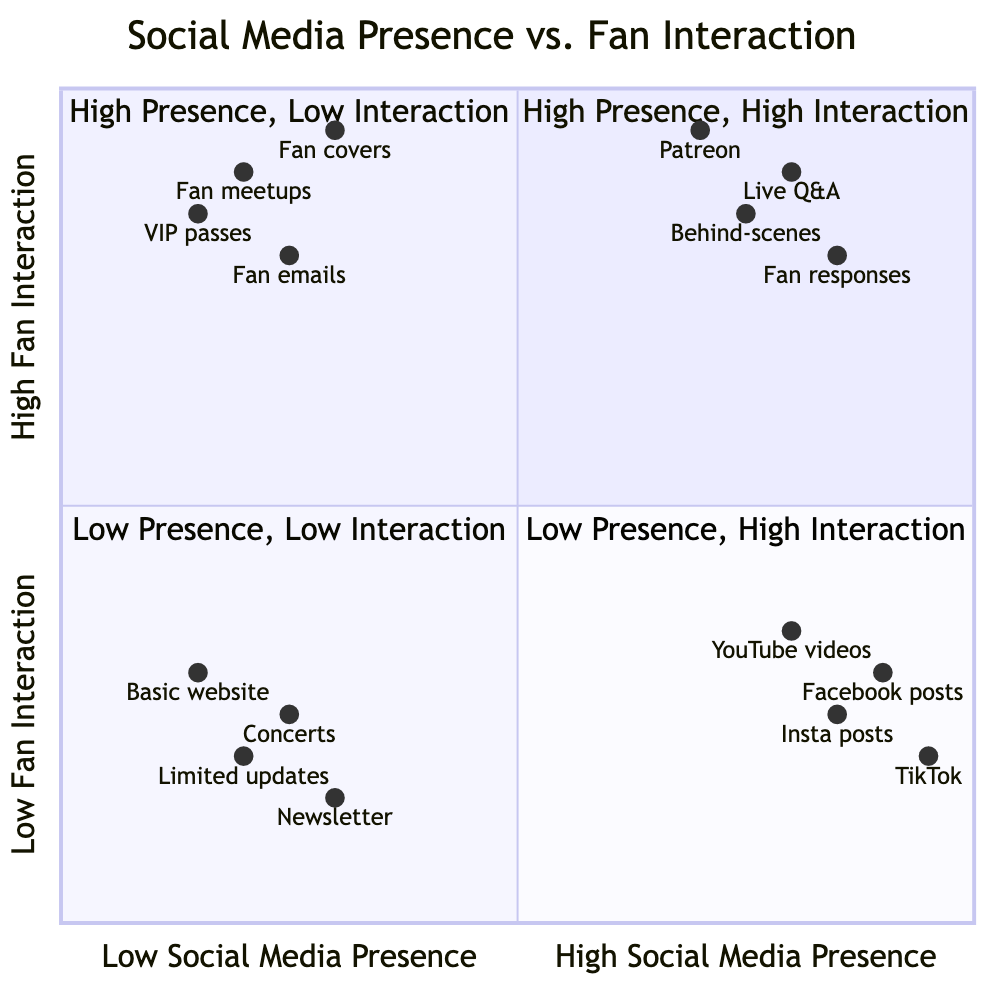What are the elements in the High Social Media Presence & High Fan Interaction quadrant? The High Social Media Presence & High Fan Interaction quadrant lists Live Q&A sessions on Instagram, Behind-the-scenes content on YouTube, Personalized fan responses on Twitter, and Exclusive Patreon content as its elements.
Answer: Live Q&A sessions on Instagram, Behind-the-scenes content on YouTube, Personalized fan responses on Twitter, Exclusive Patreon content How many elements are in the Low Social Media Presence & Low Fan Interaction quadrant? The Low Social Media Presence & Low Fan Interaction quadrant contains four elements: Limited social media updates, Occasional newsletter, Standard concert performances, and Basic website with limited interaction. Therefore, the number of elements is four.
Answer: 4 Which quadrant has elements that prioritize fan interaction but have low social media presence? The Low Social Media Presence & High Fan Interaction quadrant focuses on fan interaction, featuring elements like Exclusive fan club meetups, VIP backstage passes, Personal emails to fan mailing list, and Fan-requested covers on private streams.
Answer: Low Social Media Presence & High Fan Interaction What is the relationship between High Social Media Presence and Fan Interaction in the second quadrant? The second quadrant indicates that while there is high social media presence, fan interaction is low. It features elements like Regular Facebook posts, Professionally managed TikTok accounts, Scheduled Instagram posts, and YouTube music videos, showing a disconnect despite high visibility.
Answer: High Social Media Presence & Low Fan Interaction Which element has the highest social media presence in the diagram? To find the element with the highest social media presence, we look at the x-axis values. The highest value is for Professionally managed TikTok account, which has a value of 0.95.
Answer: Professionally managed TikTok account Which quadrant has an element that allows for personalized fan responses? The High Social Media Presence & High Fan Interaction quadrant includes the element Personalized fan responses on Twitter.
Answer: High Social Media Presence & High Fan Interaction 